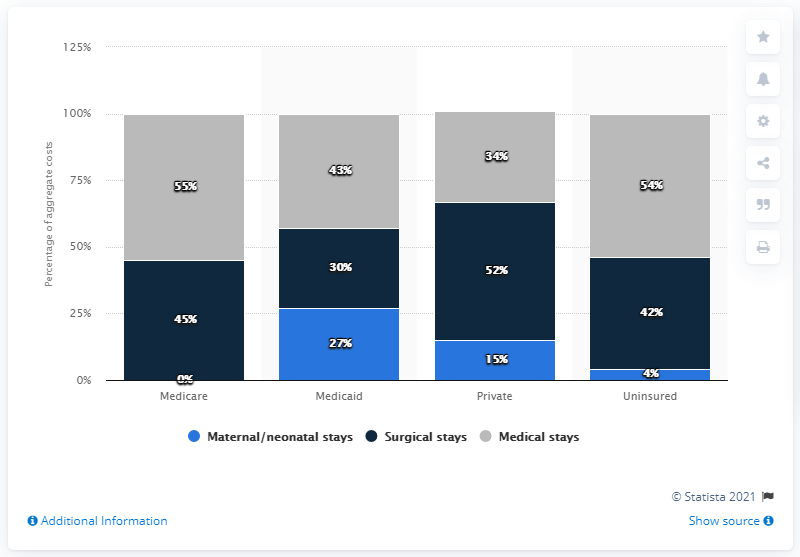Indicate a few pertinent items in this graphic. I am pleased to announce that the cost of maternal and neonatal stays is 0%. Navy blue is a color that is often associated with the medical field, specifically surgical stays. 